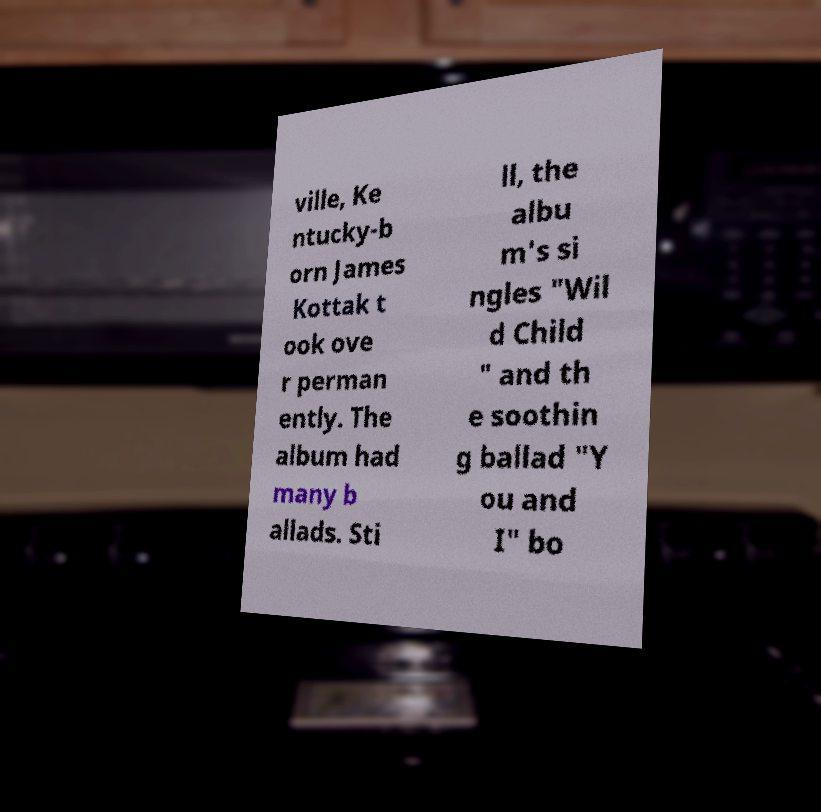Can you read and provide the text displayed in the image?This photo seems to have some interesting text. Can you extract and type it out for me? ville, Ke ntucky-b orn James Kottak t ook ove r perman ently. The album had many b allads. Sti ll, the albu m's si ngles "Wil d Child " and th e soothin g ballad "Y ou and I" bo 